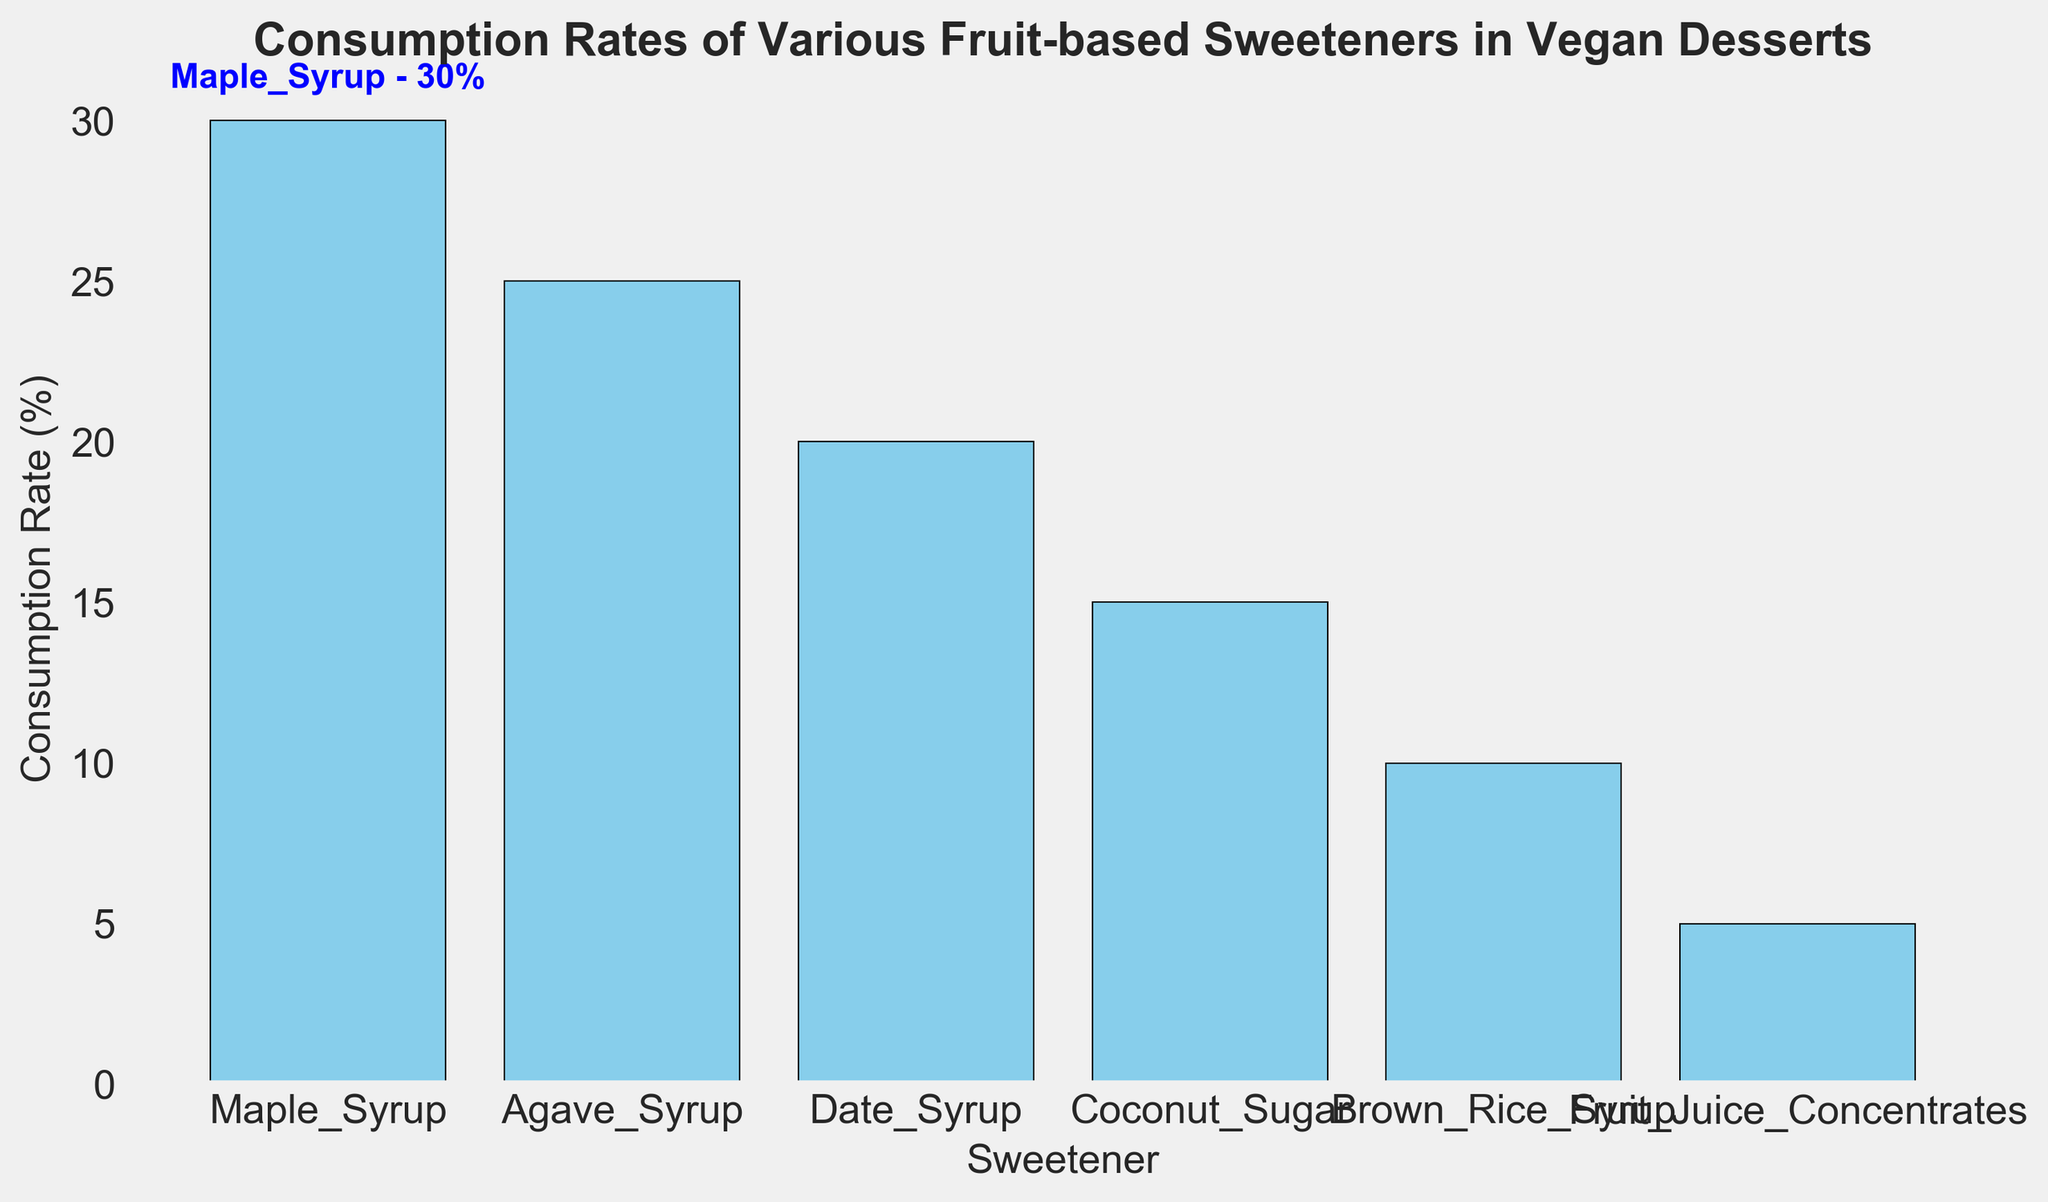What is the most consumed fruit-based sweetener in vegan desserts among families? The highest consumption rate bar has an annotation indicating "Maple_Syrup - 30%". This shows that Maple Syrup is the most consumed sweetener.
Answer: Maple Syrup Which sweetener has the lowest consumption rate? The shortest bar represents the sweetener with the lowest rate, labeled as Fruit Juice Concentrates with a 5% consumption rate.
Answer: Fruit Juice Concentrates What is the difference in consumption rates between Maple Syrup and Agave Syrup? Maple Syrup has a 30% consumption rate, Agave Syrup has 25%. Subtracting 25 from 30 gives the difference.
Answer: 5% How do the consumption rates of Date Syrup and Coconut Sugar compare? Date Syrup has a 20% rate, while Coconut Sugar has a 15% rate. Date Syrup's rate is higher.
Answer: Date Syrup's rate is higher Is the sum of the consumption rates for Brown Rice Syrup and Fruit Juice Concentrates less than the consumption rate for Maple Syrup? Brown Rice Syrup has 10% and Fruit Juice Concentrates have 5%. Summing these, 10% + 5% = 15%, which is less than Maple Syrup's 30%.
Answer: Yes Which sweeteners have a consumption rate of at least 20%? The bars representing Maple Syrup (30%), Agave Syrup (25%), and Date Syrup (20%) all meet or exceed a 20% rate.
Answer: Maple Syrup, Agave Syrup, Date Syrup What is the average consumption rate of Agave Syrup, Date Syrup, and Coconut Sugar? Agave Syrup has 25%, Date Syrup has 20%, and Coconut Sugar has 15%. Summing these and dividing by 3: (25 + 20 + 15) / 3 = 20%.
Answer: 20% Which sweetener has a consumption rate closest to 10%? The bar representing Brown Rice Syrup is labeled with a consumption rate of 10%.
Answer: Brown Rice Syrup How much higher is Coconut Sugar's consumption rate compared to Fruit Juice Concentrates? Coconut Sugar has 15%, Fruit Juice Concentrates have 5%. Subtracting 5 from 15 gives the difference.
Answer: 10% Are the consumption rates of Brown Rice Syrup and Fruit Juice Concentrates combined higher than Date Syrup alone? The combined rate for Brown Rice Syrup (10%) and Fruit Juice Concentrates (5%) is 15%, which is lower than Date Syrup's 20%.
Answer: No 